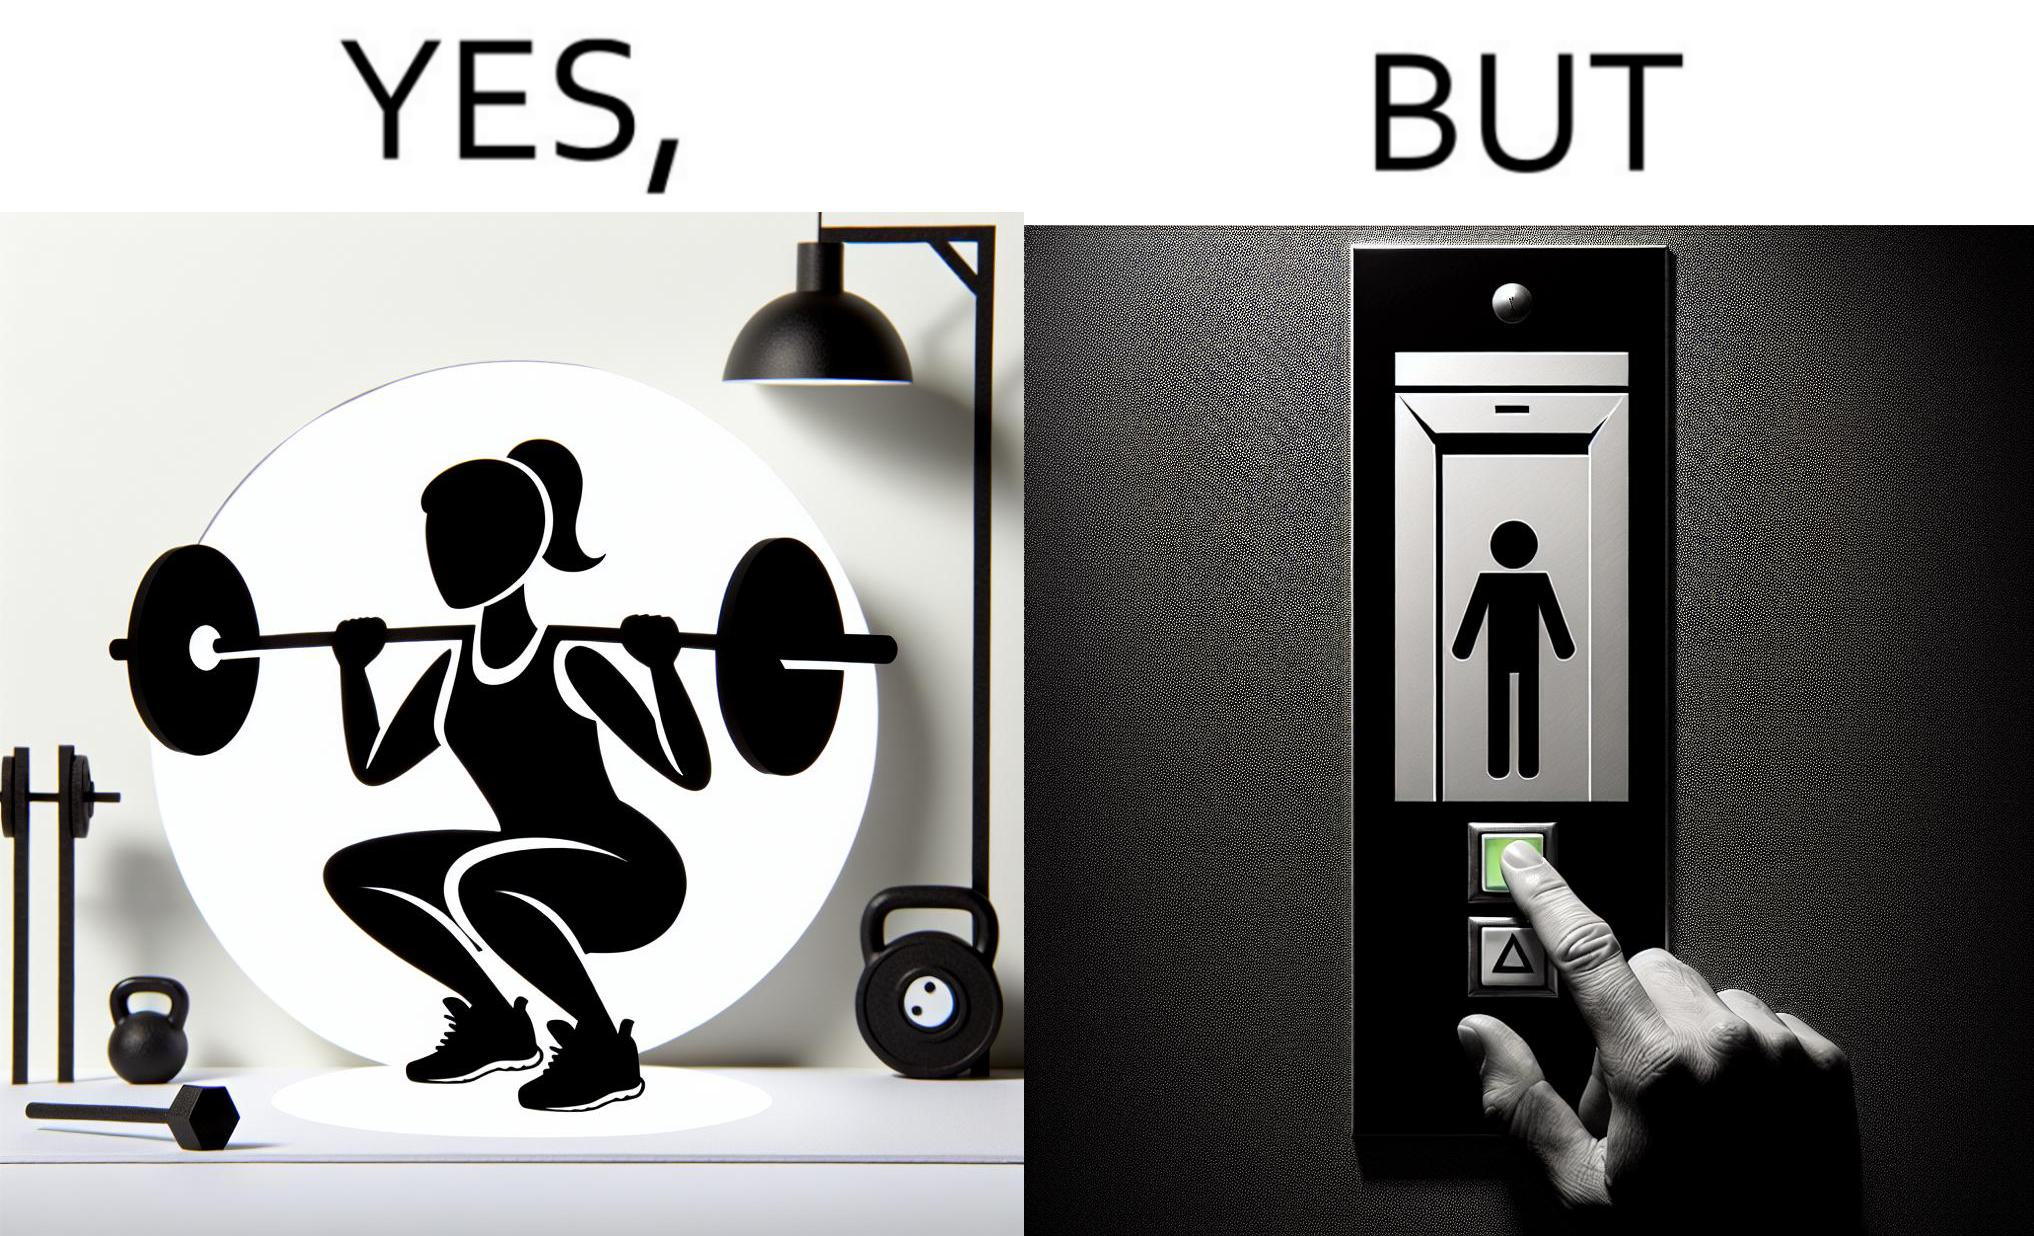Does this image contain satire or humor? Yes, this image is satirical. 